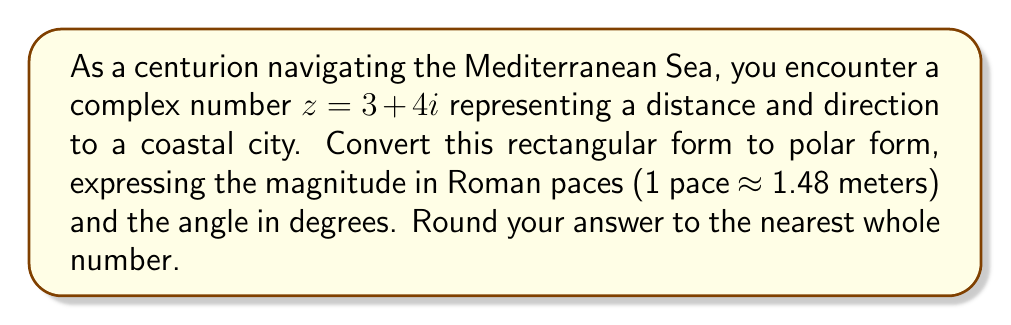What is the answer to this math problem? 1) To convert from rectangular form $(a + bi)$ to polar form $(r \angle \theta)$, we use:

   $r = \sqrt{a^2 + b^2}$
   $\theta = \tan^{-1}(\frac{b}{a})$

2) For $z = 3 + 4i$:
   $r = \sqrt{3^2 + 4^2} = \sqrt{9 + 16} = \sqrt{25} = 5$

3) $\theta = \tan^{-1}(\frac{4}{3}) \approx 53.13°$

4) Convert 5 units to Roman paces:
   $5 \times 1.48 \approx 7.4$ paces

5) Rounding to the nearest whole number:
   Magnitude: 7 paces
   Angle: 53°

Therefore, in polar form: $7 \angle 53°$
Answer: $7 \angle 53°$ 